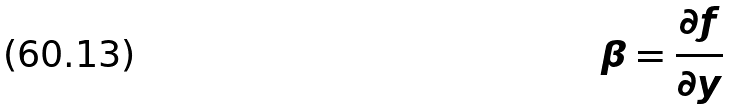Convert formula to latex. <formula><loc_0><loc_0><loc_500><loc_500>\beta = \frac { \partial f } { \partial y }</formula> 